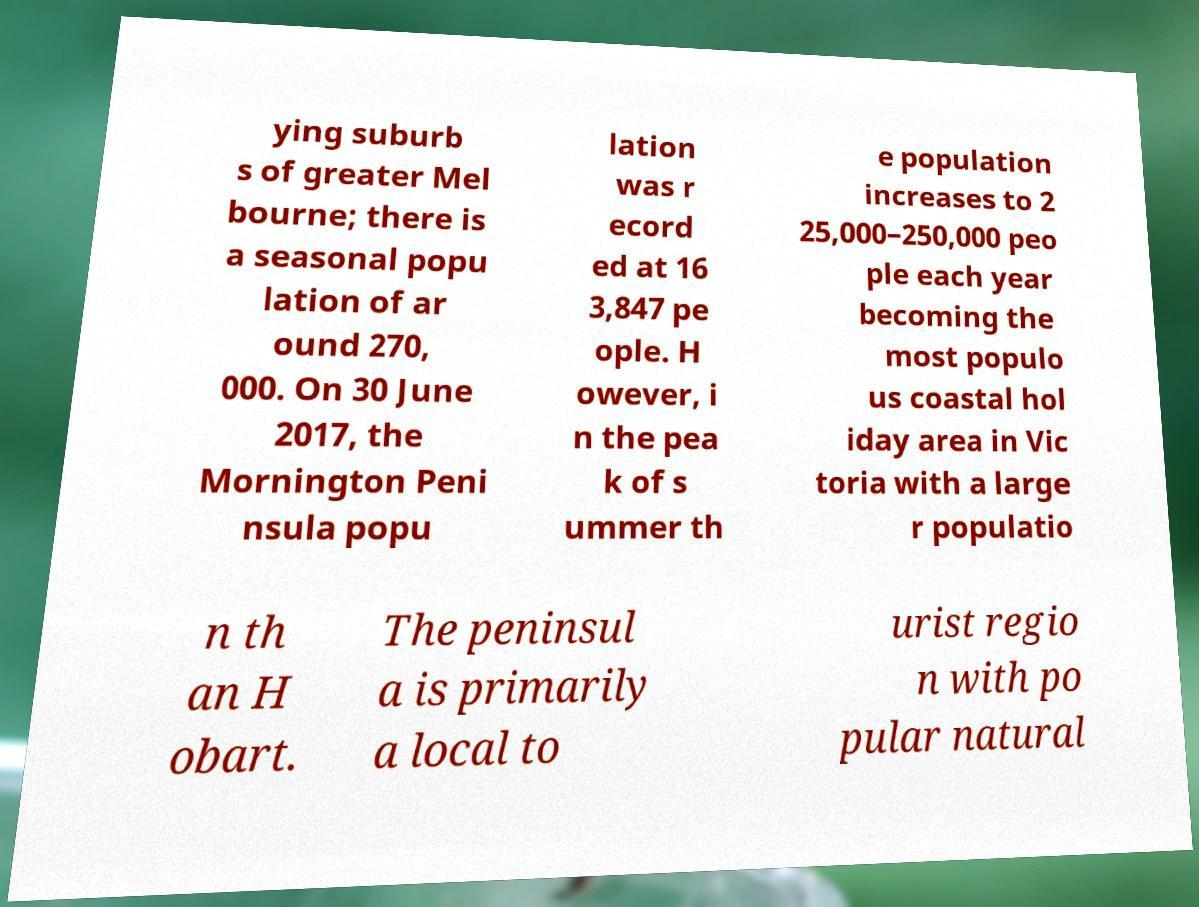Could you extract and type out the text from this image? ying suburb s of greater Mel bourne; there is a seasonal popu lation of ar ound 270, 000. On 30 June 2017, the Mornington Peni nsula popu lation was r ecord ed at 16 3,847 pe ople. H owever, i n the pea k of s ummer th e population increases to 2 25,000–250,000 peo ple each year becoming the most populo us coastal hol iday area in Vic toria with a large r populatio n th an H obart. The peninsul a is primarily a local to urist regio n with po pular natural 